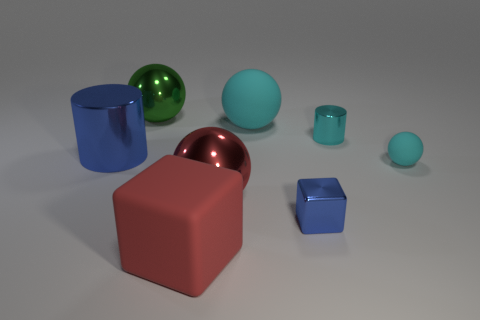Add 1 blue metallic cubes. How many objects exist? 9 Subtract all blocks. How many objects are left? 6 Subtract 0 purple blocks. How many objects are left? 8 Subtract all small yellow objects. Subtract all large cyan matte balls. How many objects are left? 7 Add 1 tiny cubes. How many tiny cubes are left? 2 Add 5 shiny objects. How many shiny objects exist? 10 